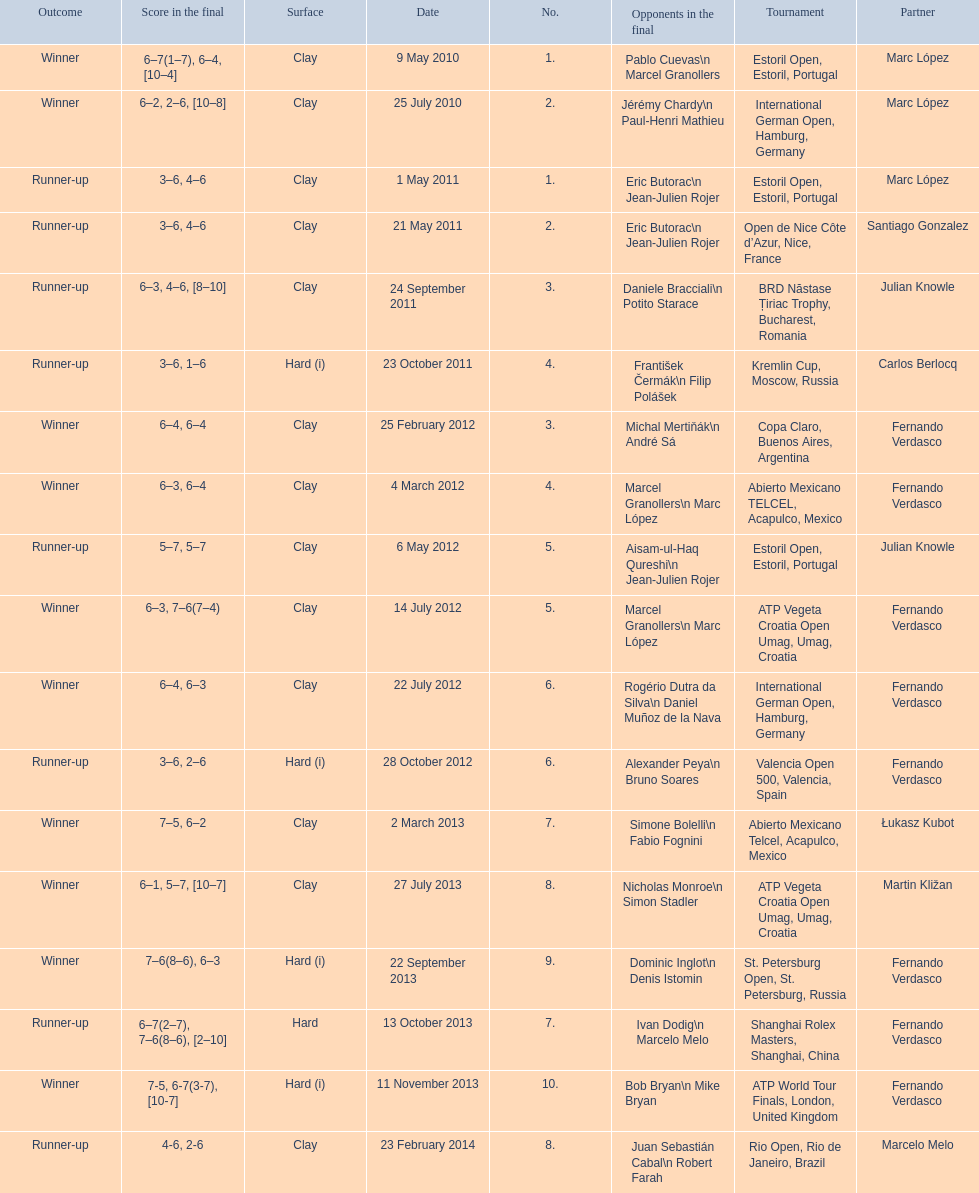How many runner-ups at most are listed? 8. 